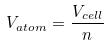<formula> <loc_0><loc_0><loc_500><loc_500>V _ { a t o m } = \frac { V _ { c e l l } } { n }</formula> 